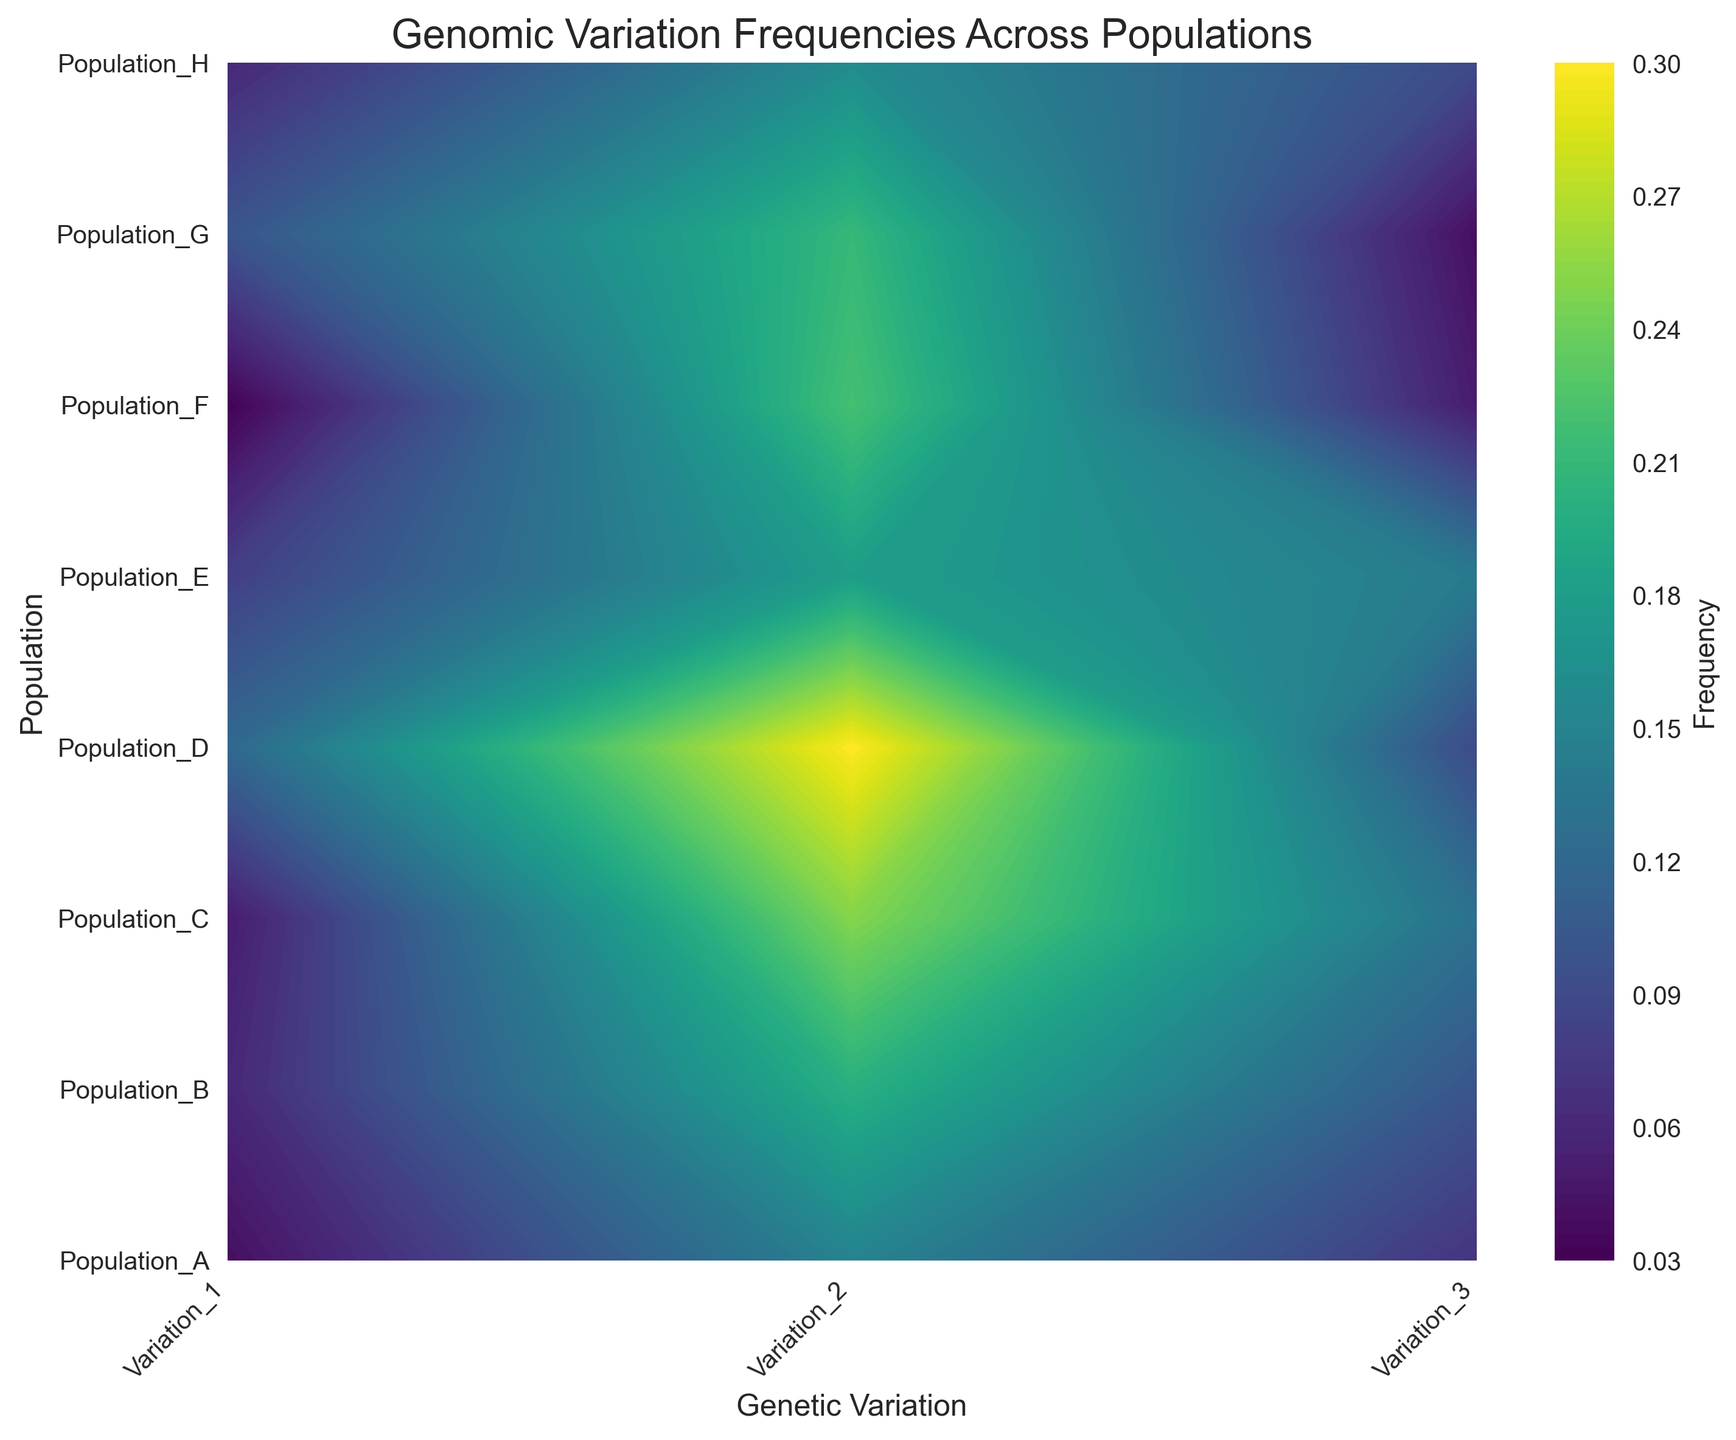Which population has the highest frequency of Variation_2? Look at the contour plot and identify the color intensity for Variation_2 across all populations. The highest color intensity corresponds to the highest frequency.
Answer: Population_D Is there any population where Variation_1 has a lower frequency than Variation_3? Compare the color intensities for Variation_1 and Variation_3 across all populations. Identify if any population shows a darker (lower frequency) color for Variation_1 compared to Variation_3.
Answer: Yes, Population_H Which genetic variation has the most uniformly distributed frequency across all populations? Observe the contour plot and look for the genetic variation column that shows the least variation in color intensity across populations.
Answer: Variation_3 What is the average frequency of Variation_1 across all populations? Sum the frequencies of Variation_1 for all populations and divide by the number of populations. (0.04 + 0.06 + 0.05 + 0.12 + 0.08 + 0.03 + 0.1 + 0.06) / 8 = 0.06875
Answer: 0.06875 Which population has the highest variation in frequencies across the three genetic variations? Examine the color intensity variations for each population across the three genetic variations. Identify the population with the most varied color intensities.
Answer: Population_D How does the frequency of Variation_2 in Population_A compare to the frequency of Variation_2 in Population_F? Compare the color intensities in Population_A and Population_F for Variation_2 directly from the contour plot.
Answer: Population_F has a higher frequency Is there a disease associated with multiple genetic variations within any population? This information is not directly derivable from the contour plot as it requires understanding the associations of diseases with variations, which are not visualized here.
Answer: Not derivable from plot Can you identify any regions where the frequency of a genetic variation is particularly low across multiple populations? Look for regions with consistently darker colors across multiple populations for any genetic variation.
Answer: Variation_1 across several populations What is the geometric mean of the frequencies for Variation_3 across all populations? Calculate the geometric mean of the frequencies for Variation_3 using the formula: (Product of all values)^(1/n). (0.07 * 0.1 * 0.13 * 0.09 * 0.14 * 0.05 * 0.04 * 0.09)^(1/8).
Answer: ≈ 0.080 Which genetic variation exhibits the highest peak frequency? Identify the genetic variation column on the contour plot that shows the brightest (highest frequency) color in any population.
Answer: Variation_2 